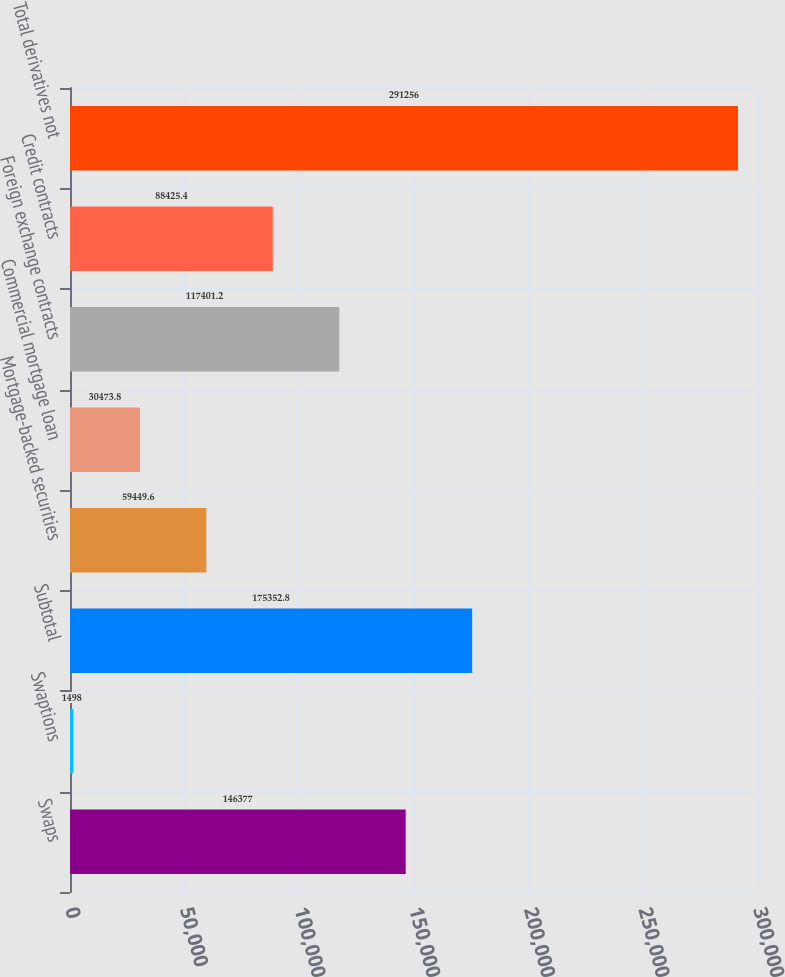Convert chart to OTSL. <chart><loc_0><loc_0><loc_500><loc_500><bar_chart><fcel>Swaps<fcel>Swaptions<fcel>Subtotal<fcel>Mortgage-backed securities<fcel>Commercial mortgage loan<fcel>Foreign exchange contracts<fcel>Credit contracts<fcel>Total derivatives not<nl><fcel>146377<fcel>1498<fcel>175353<fcel>59449.6<fcel>30473.8<fcel>117401<fcel>88425.4<fcel>291256<nl></chart> 